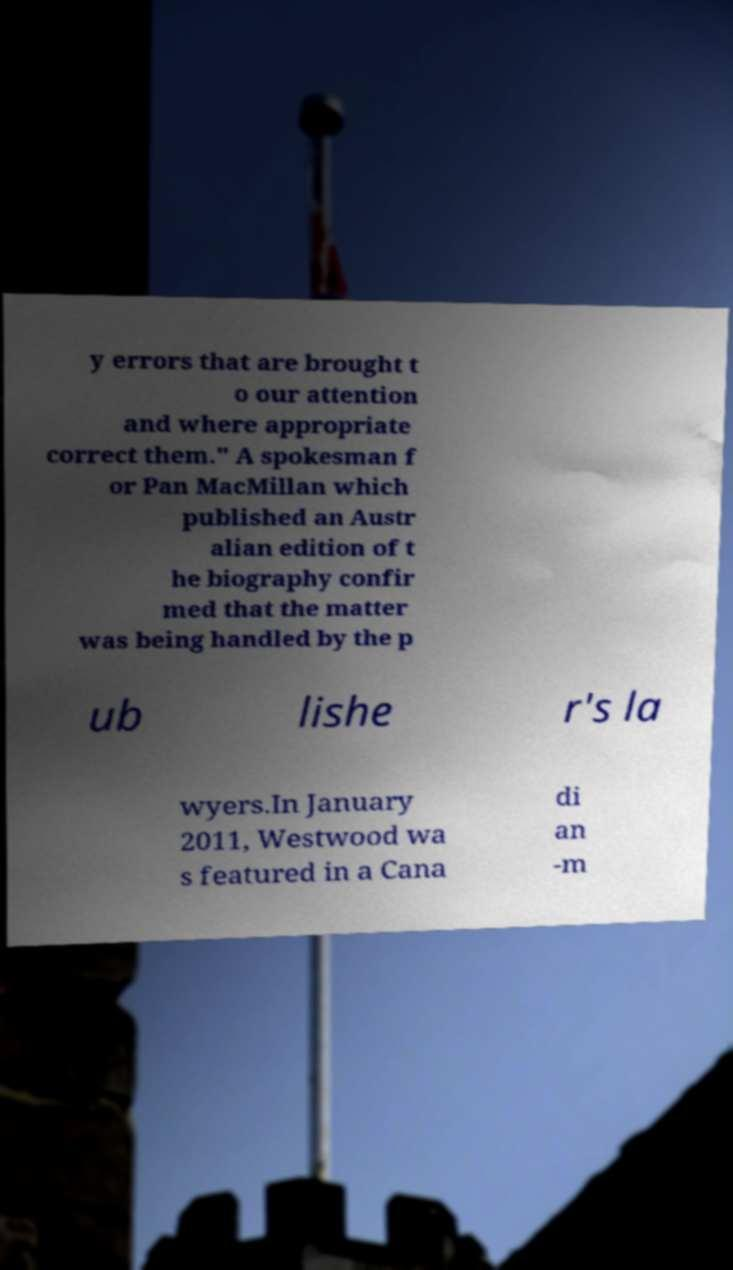There's text embedded in this image that I need extracted. Can you transcribe it verbatim? y errors that are brought t o our attention and where appropriate correct them." A spokesman f or Pan MacMillan which published an Austr alian edition of t he biography confir med that the matter was being handled by the p ub lishe r's la wyers.In January 2011, Westwood wa s featured in a Cana di an -m 